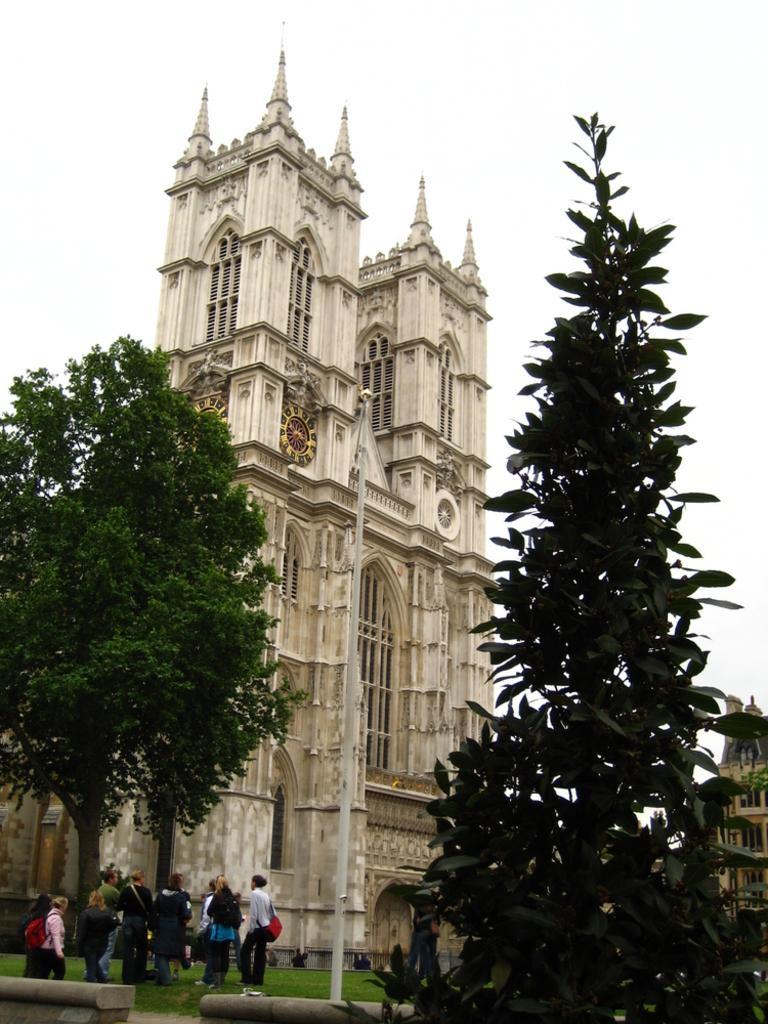Could you give a brief overview of what you see in this image? In this picture we can see people on the ground,here we can see a pole,trees,buildings and we can see sky in the background. 